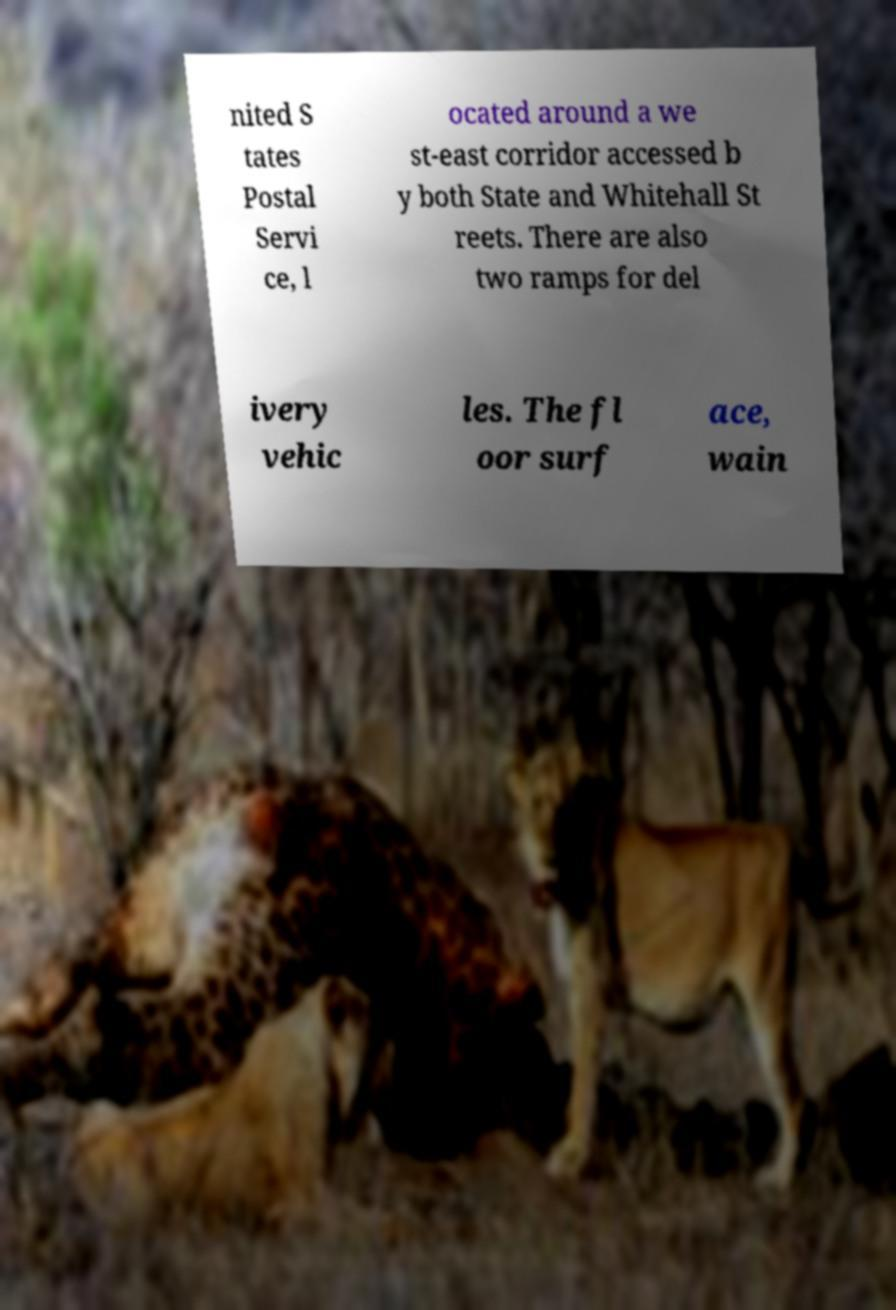Can you accurately transcribe the text from the provided image for me? nited S tates Postal Servi ce, l ocated around a we st-east corridor accessed b y both State and Whitehall St reets. There are also two ramps for del ivery vehic les. The fl oor surf ace, wain 